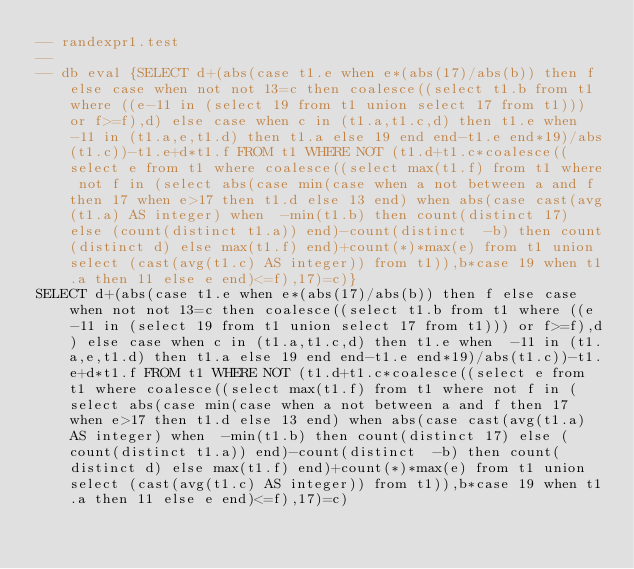<code> <loc_0><loc_0><loc_500><loc_500><_SQL_>-- randexpr1.test
-- 
-- db eval {SELECT d+(abs(case t1.e when e*(abs(17)/abs(b)) then f else case when not not 13=c then coalesce((select t1.b from t1 where ((e-11 in (select 19 from t1 union select 17 from t1))) or f>=f),d) else case when c in (t1.a,t1.c,d) then t1.e when  -11 in (t1.a,e,t1.d) then t1.a else 19 end end-t1.e end*19)/abs(t1.c))-t1.e+d*t1.f FROM t1 WHERE NOT (t1.d+t1.c*coalesce((select e from t1 where coalesce((select max(t1.f) from t1 where not f in (select abs(case min(case when a not between a and f then 17 when e>17 then t1.d else 13 end) when abs(case cast(avg(t1.a) AS integer) when  -min(t1.b) then count(distinct 17) else (count(distinct t1.a)) end)-count(distinct  -b) then count(distinct d) else max(t1.f) end)+count(*)*max(e) from t1 union select (cast(avg(t1.c) AS integer)) from t1)),b*case 19 when t1.a then 11 else e end)<=f),17)=c)}
SELECT d+(abs(case t1.e when e*(abs(17)/abs(b)) then f else case when not not 13=c then coalesce((select t1.b from t1 where ((e-11 in (select 19 from t1 union select 17 from t1))) or f>=f),d) else case when c in (t1.a,t1.c,d) then t1.e when  -11 in (t1.a,e,t1.d) then t1.a else 19 end end-t1.e end*19)/abs(t1.c))-t1.e+d*t1.f FROM t1 WHERE NOT (t1.d+t1.c*coalesce((select e from t1 where coalesce((select max(t1.f) from t1 where not f in (select abs(case min(case when a not between a and f then 17 when e>17 then t1.d else 13 end) when abs(case cast(avg(t1.a) AS integer) when  -min(t1.b) then count(distinct 17) else (count(distinct t1.a)) end)-count(distinct  -b) then count(distinct d) else max(t1.f) end)+count(*)*max(e) from t1 union select (cast(avg(t1.c) AS integer)) from t1)),b*case 19 when t1.a then 11 else e end)<=f),17)=c)</code> 